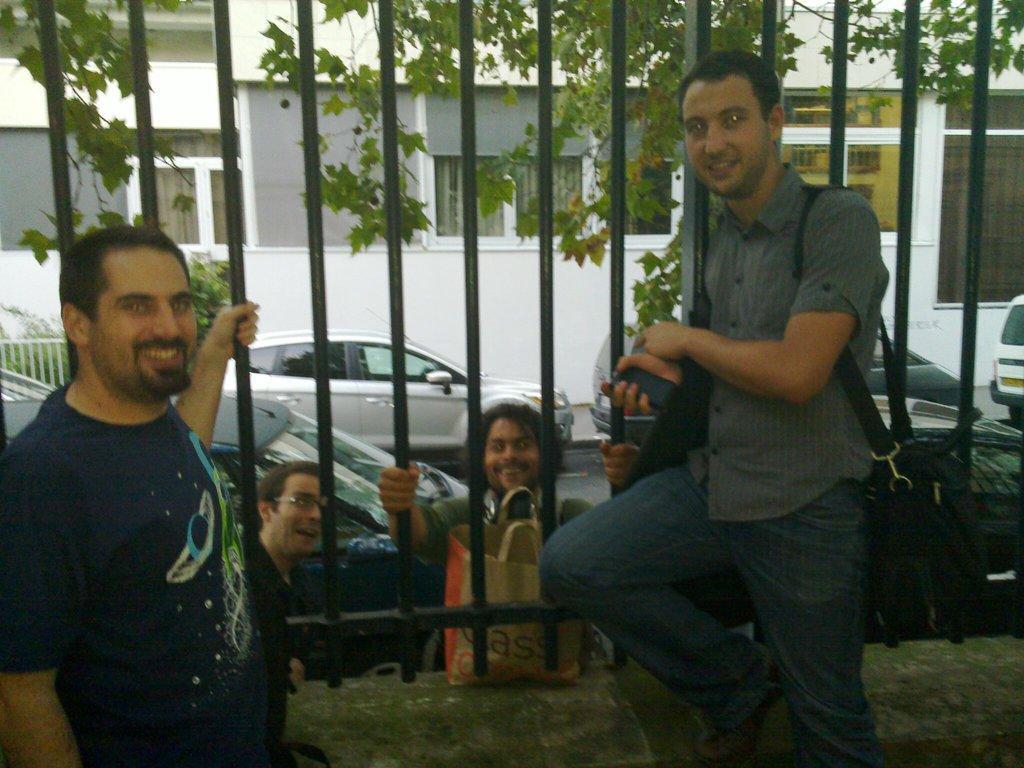How would you summarize this image in a sentence or two? In this picture I can see two people are in front of the grills, other side of the grilles I can see few people with bag, vehicles, trees and some buildings. 